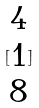<formula> <loc_0><loc_0><loc_500><loc_500>[ \begin{matrix} 4 \\ 1 \\ 8 \end{matrix} ]</formula> 